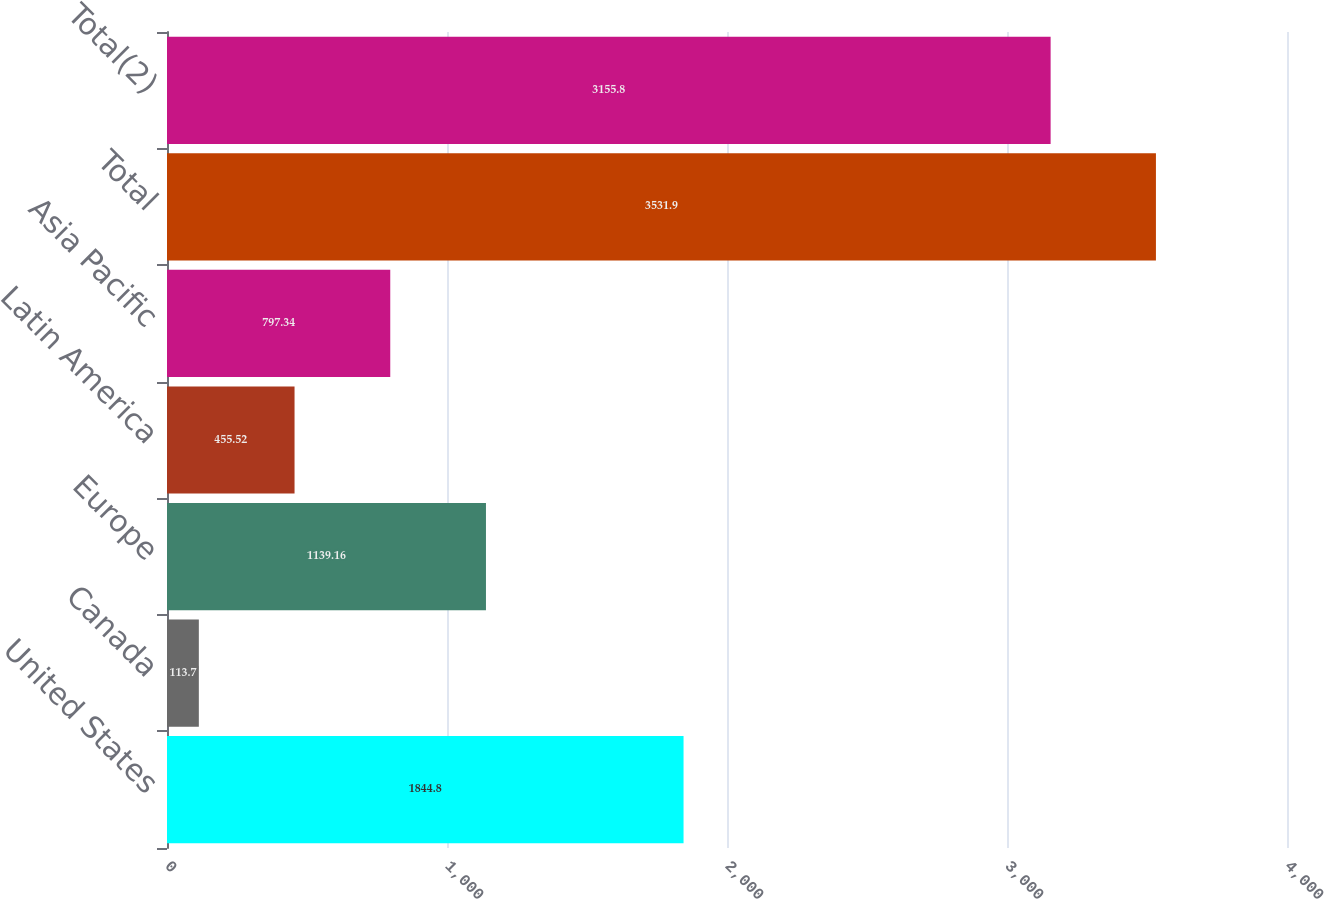<chart> <loc_0><loc_0><loc_500><loc_500><bar_chart><fcel>United States<fcel>Canada<fcel>Europe<fcel>Latin America<fcel>Asia Pacific<fcel>Total<fcel>Total(2)<nl><fcel>1844.8<fcel>113.7<fcel>1139.16<fcel>455.52<fcel>797.34<fcel>3531.9<fcel>3155.8<nl></chart> 